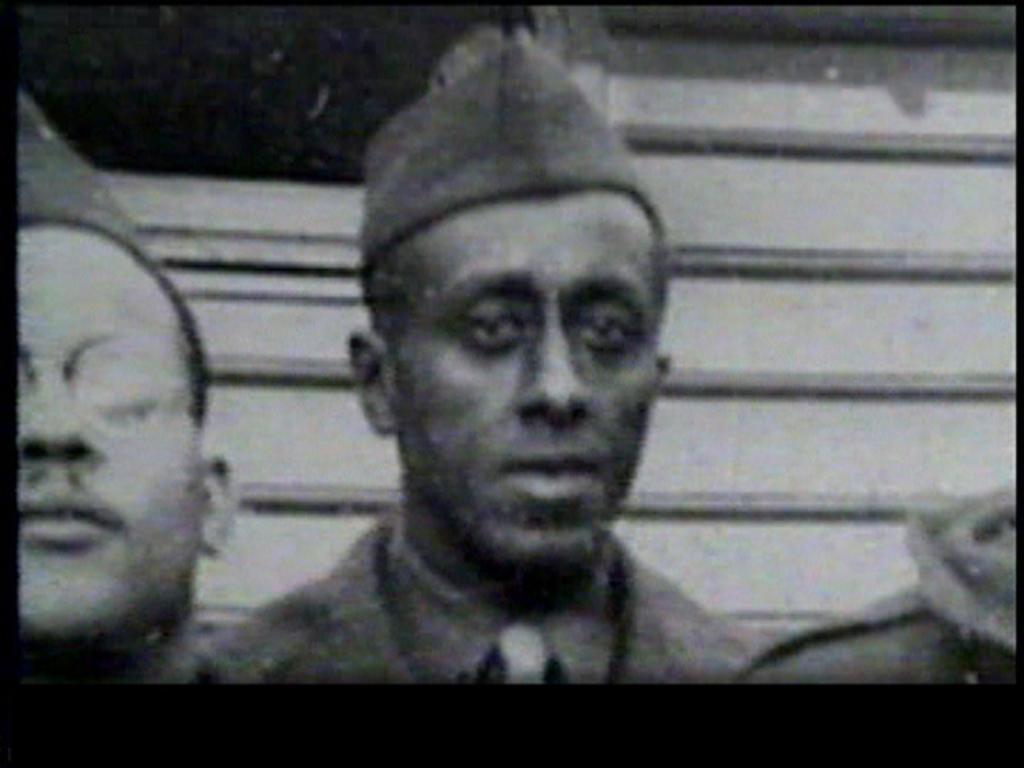In one or two sentences, can you explain what this image depicts? These image is a black and white image in which in center there is a person wearing a cap. At the left side of the image there is a person who is wearing spectacles. 